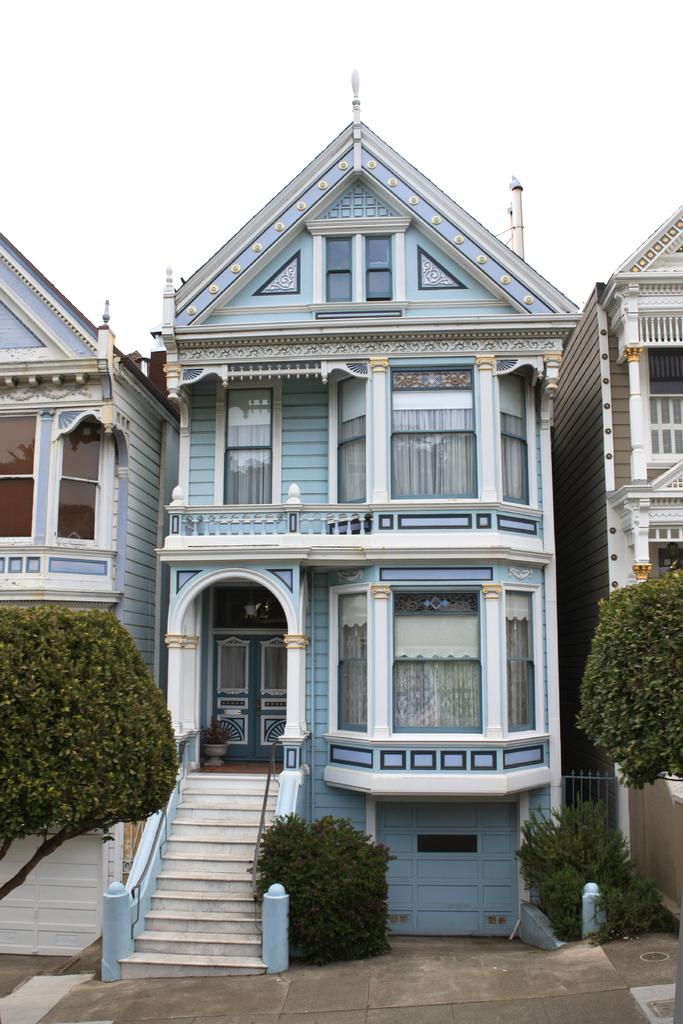What type of structures are visible in the image? There are buildings in the image. What features can be seen on the buildings? The buildings have windows, doors, and steps. What additional elements are present in the image? There is a house plant, trees, and a path visible. Are there any interior details visible in the image? Yes, there are curtains in the image. What type of turkey can be seen walking along the path in the image? There is no turkey present in the image; it only features buildings, a house plant, trees, and a path. What type of fork is used to hold the curtains in the image? There is no fork present in the image, and the curtains are not being held by any object. 